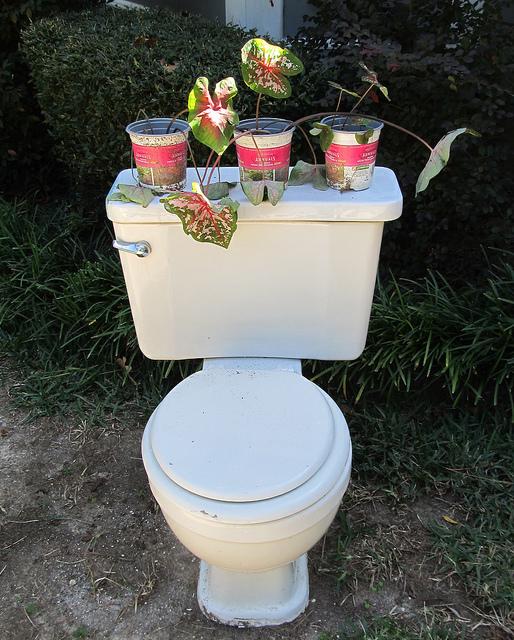How many potted plants do you see?
Give a very brief answer. 3. What are the potted plants sitting on?
Write a very short answer. Toilet. Why is the object in this photo out of place?
Write a very short answer. Toilet. Is there someone sitting?
Answer briefly. No. 